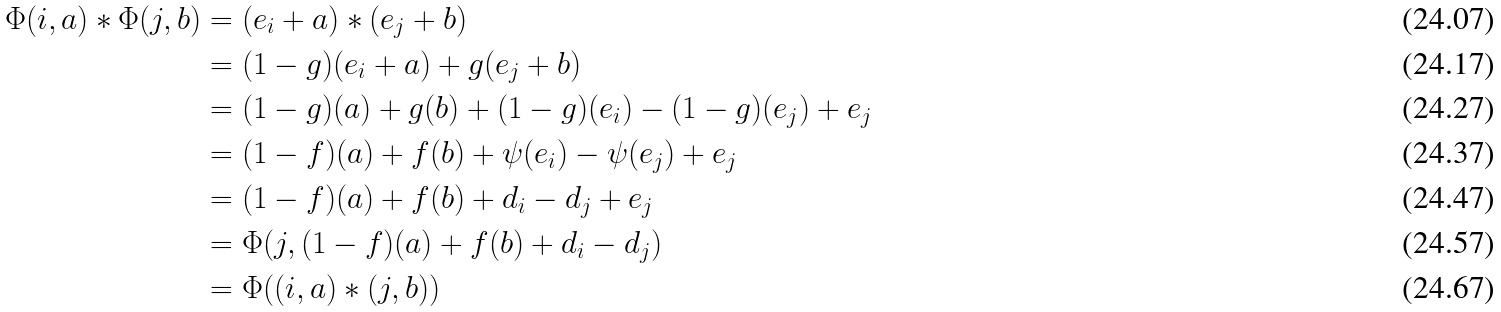<formula> <loc_0><loc_0><loc_500><loc_500>\Phi ( i , a ) * \Phi ( j , b ) & = ( e _ { i } + a ) * ( e _ { j } + b ) \\ & = ( 1 - g ) ( e _ { i } + a ) + g ( e _ { j } + b ) \\ & = ( 1 - g ) ( a ) + g ( b ) + ( 1 - g ) ( e _ { i } ) - ( 1 - g ) ( e _ { j } ) + e _ { j } \\ & = ( 1 - f ) ( a ) + f ( b ) + \psi ( e _ { i } ) - \psi ( e _ { j } ) + e _ { j } \\ & = ( 1 - f ) ( a ) + f ( b ) + d _ { i } - d _ { j } + e _ { j } \\ & = \Phi ( j , ( 1 - f ) ( a ) + f ( b ) + d _ { i } - d _ { j } ) \\ & = \Phi ( ( i , a ) * ( j , b ) )</formula> 